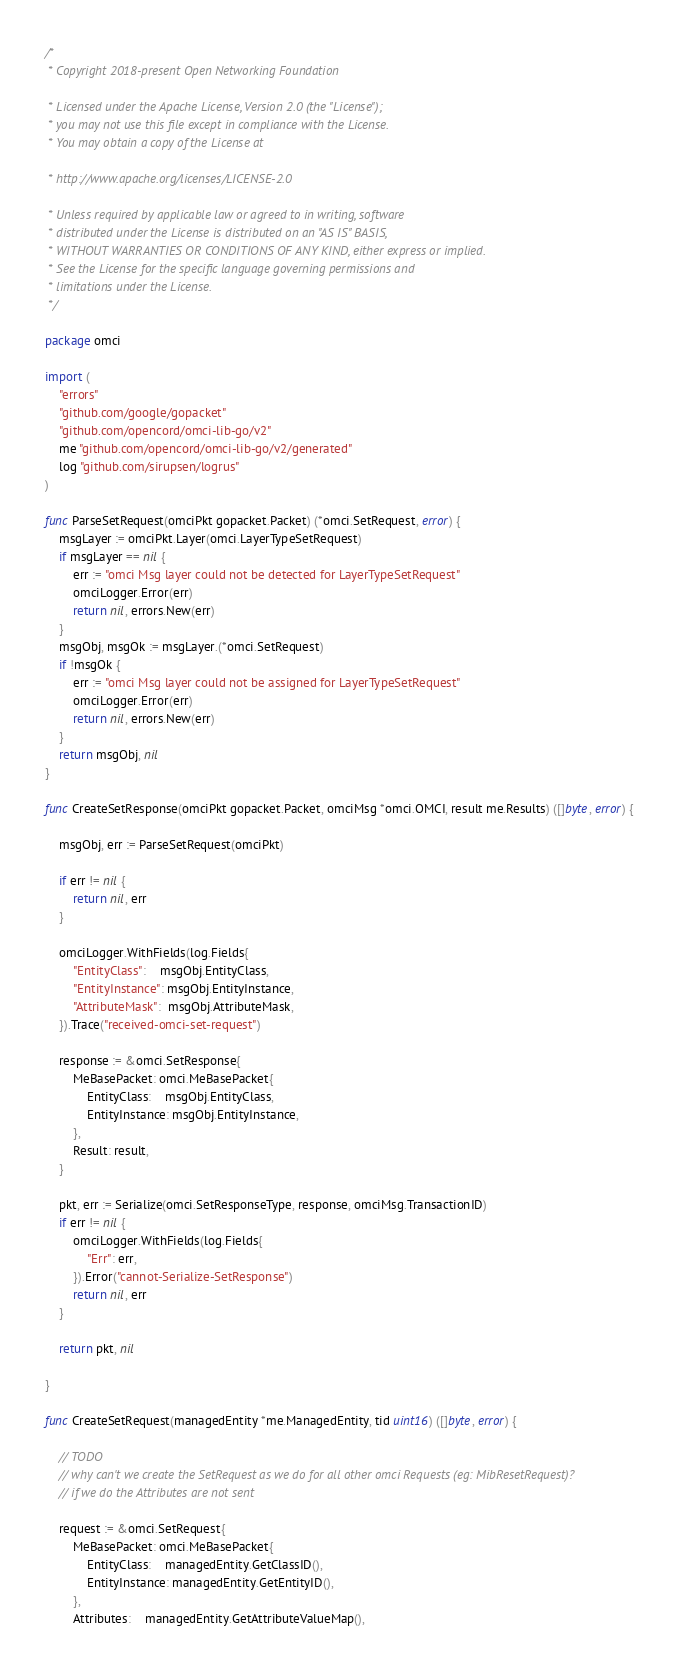Convert code to text. <code><loc_0><loc_0><loc_500><loc_500><_Go_>/*
 * Copyright 2018-present Open Networking Foundation

 * Licensed under the Apache License, Version 2.0 (the "License");
 * you may not use this file except in compliance with the License.
 * You may obtain a copy of the License at

 * http://www.apache.org/licenses/LICENSE-2.0

 * Unless required by applicable law or agreed to in writing, software
 * distributed under the License is distributed on an "AS IS" BASIS,
 * WITHOUT WARRANTIES OR CONDITIONS OF ANY KIND, either express or implied.
 * See the License for the specific language governing permissions and
 * limitations under the License.
 */

package omci

import (
	"errors"
	"github.com/google/gopacket"
	"github.com/opencord/omci-lib-go/v2"
	me "github.com/opencord/omci-lib-go/v2/generated"
	log "github.com/sirupsen/logrus"
)

func ParseSetRequest(omciPkt gopacket.Packet) (*omci.SetRequest, error) {
	msgLayer := omciPkt.Layer(omci.LayerTypeSetRequest)
	if msgLayer == nil {
		err := "omci Msg layer could not be detected for LayerTypeSetRequest"
		omciLogger.Error(err)
		return nil, errors.New(err)
	}
	msgObj, msgOk := msgLayer.(*omci.SetRequest)
	if !msgOk {
		err := "omci Msg layer could not be assigned for LayerTypeSetRequest"
		omciLogger.Error(err)
		return nil, errors.New(err)
	}
	return msgObj, nil
}

func CreateSetResponse(omciPkt gopacket.Packet, omciMsg *omci.OMCI, result me.Results) ([]byte, error) {

	msgObj, err := ParseSetRequest(omciPkt)

	if err != nil {
		return nil, err
	}

	omciLogger.WithFields(log.Fields{
		"EntityClass":    msgObj.EntityClass,
		"EntityInstance": msgObj.EntityInstance,
		"AttributeMask":  msgObj.AttributeMask,
	}).Trace("received-omci-set-request")

	response := &omci.SetResponse{
		MeBasePacket: omci.MeBasePacket{
			EntityClass:    msgObj.EntityClass,
			EntityInstance: msgObj.EntityInstance,
		},
		Result: result,
	}

	pkt, err := Serialize(omci.SetResponseType, response, omciMsg.TransactionID)
	if err != nil {
		omciLogger.WithFields(log.Fields{
			"Err": err,
		}).Error("cannot-Serialize-SetResponse")
		return nil, err
	}

	return pkt, nil

}

func CreateSetRequest(managedEntity *me.ManagedEntity, tid uint16) ([]byte, error) {

	// TODO
	// why can't we create the SetRequest as we do for all other omci Requests (eg: MibResetRequest)?
	// if we do the Attributes are not sent

	request := &omci.SetRequest{
		MeBasePacket: omci.MeBasePacket{
			EntityClass:    managedEntity.GetClassID(),
			EntityInstance: managedEntity.GetEntityID(),
		},
		Attributes:    managedEntity.GetAttributeValueMap(),</code> 